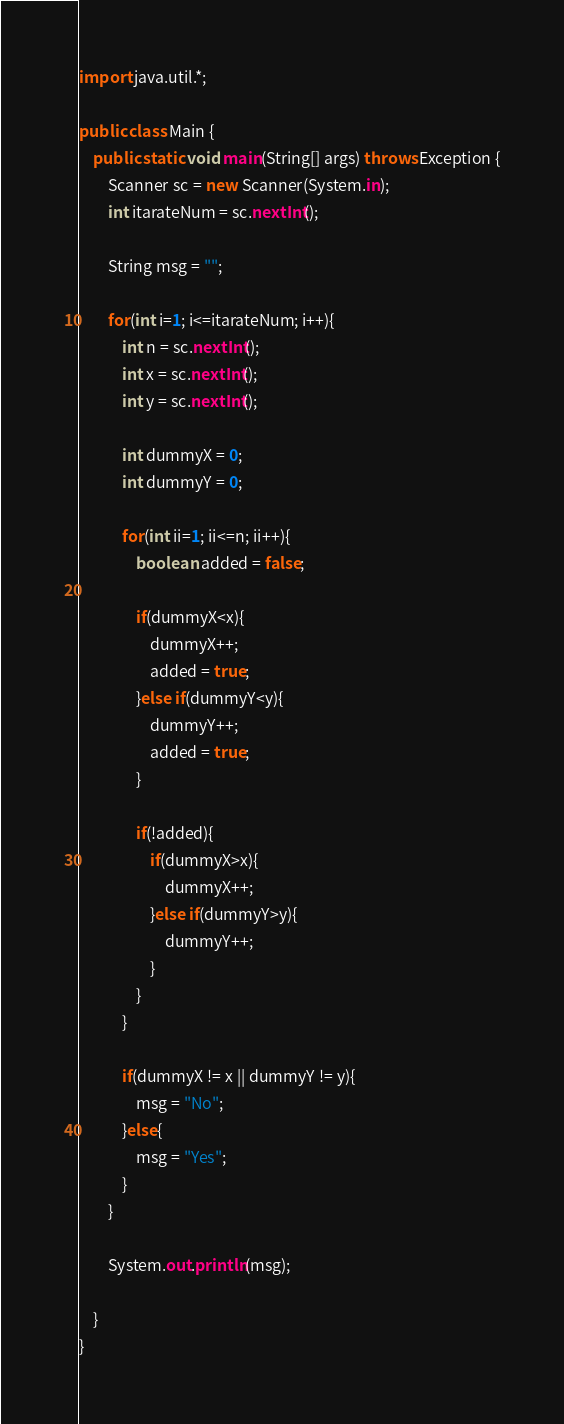<code> <loc_0><loc_0><loc_500><loc_500><_Java_>import java.util.*;

public class Main {
    public static void main(String[] args) throws Exception {
        Scanner sc = new Scanner(System.in);
        int itarateNum = sc.nextInt();
        
        String msg = "";
        
        for(int i=1; i<=itarateNum; i++){
            int n = sc.nextInt();
            int x = sc.nextInt();
            int y = sc.nextInt();
            
            int dummyX = 0;
            int dummyY = 0;
            
            for(int ii=1; ii<=n; ii++){
                boolean added = false;
                
                if(dummyX<x){
                    dummyX++;
                    added = true;
                }else if(dummyY<y){
                    dummyY++;
                    added = true;
                }
                
                if(!added){
                    if(dummyX>x){
                        dummyX++;
                    }else if(dummyY>y){
                        dummyY++;
                    }
                }
            }
            
            if(dummyX != x || dummyY != y){
                msg = "No";
            }else{
                msg = "Yes";
            }
        }
        
        System.out.println(msg);

    }
}
</code> 